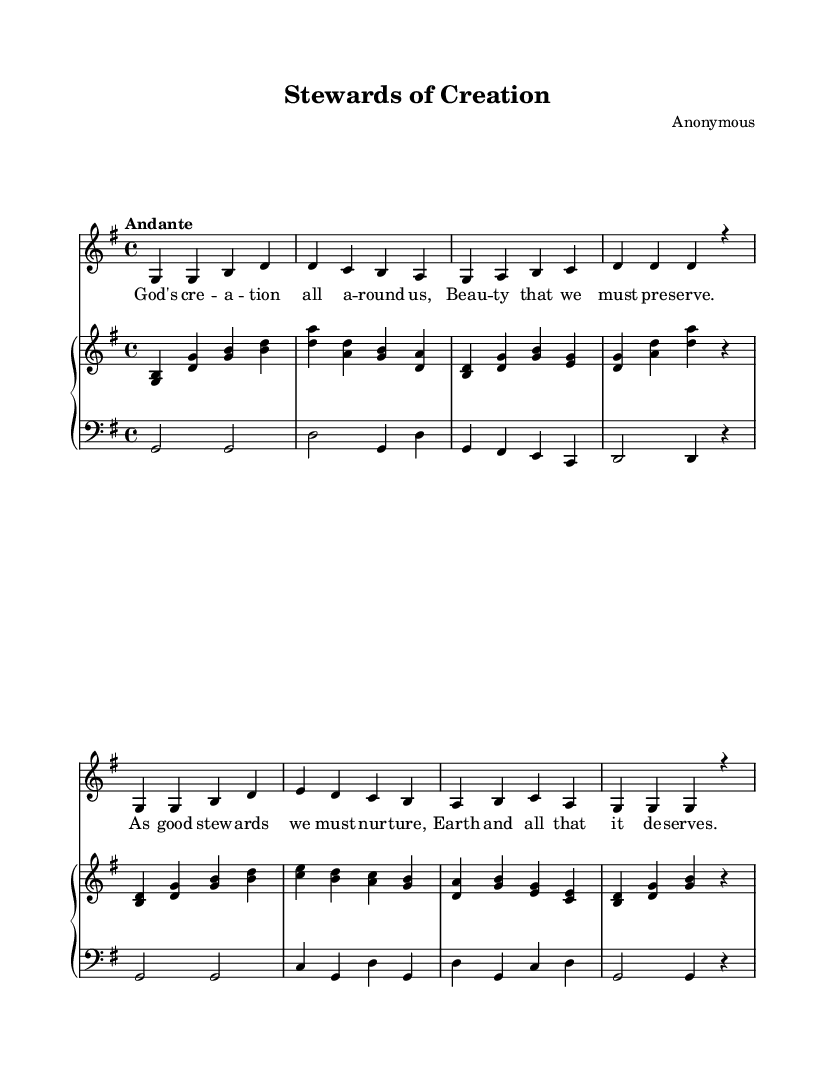What is the key signature of this music? The key signature is indicated at the beginning of the score, and here it shows one sharp, which corresponds to G major.
Answer: G major What is the time signature of this piece? The time signature is displayed at the beginning of the score, where it indicates four beats per measure, specifically 4/4.
Answer: 4/4 What is the tempo marking for this piece? The tempo marking is noted above the music, written as "Andante," which suggests a moderately slow pace.
Answer: Andante How many measures does the melody consist of? By counting the groups of notes separated by vertical lines, we find there are eight measures in the melody.
Answer: Eight What is the title of the hymn? The title is found in the header section of the score, specifically labeled at the top as "Stewards of Creation."
Answer: Stewards of Creation What thematic focus does the hymn emphasize? The lyrics reflect a focus on environmental stewardship and caring for God's creation, emphasizing the necessity to preserve beauty.
Answer: Environmental stewardship Which voice part carries the melody? The melody is specifically indicated by the label "Voice" and is assigned to "melody," which is the topmost voice in the score.
Answer: Melody 